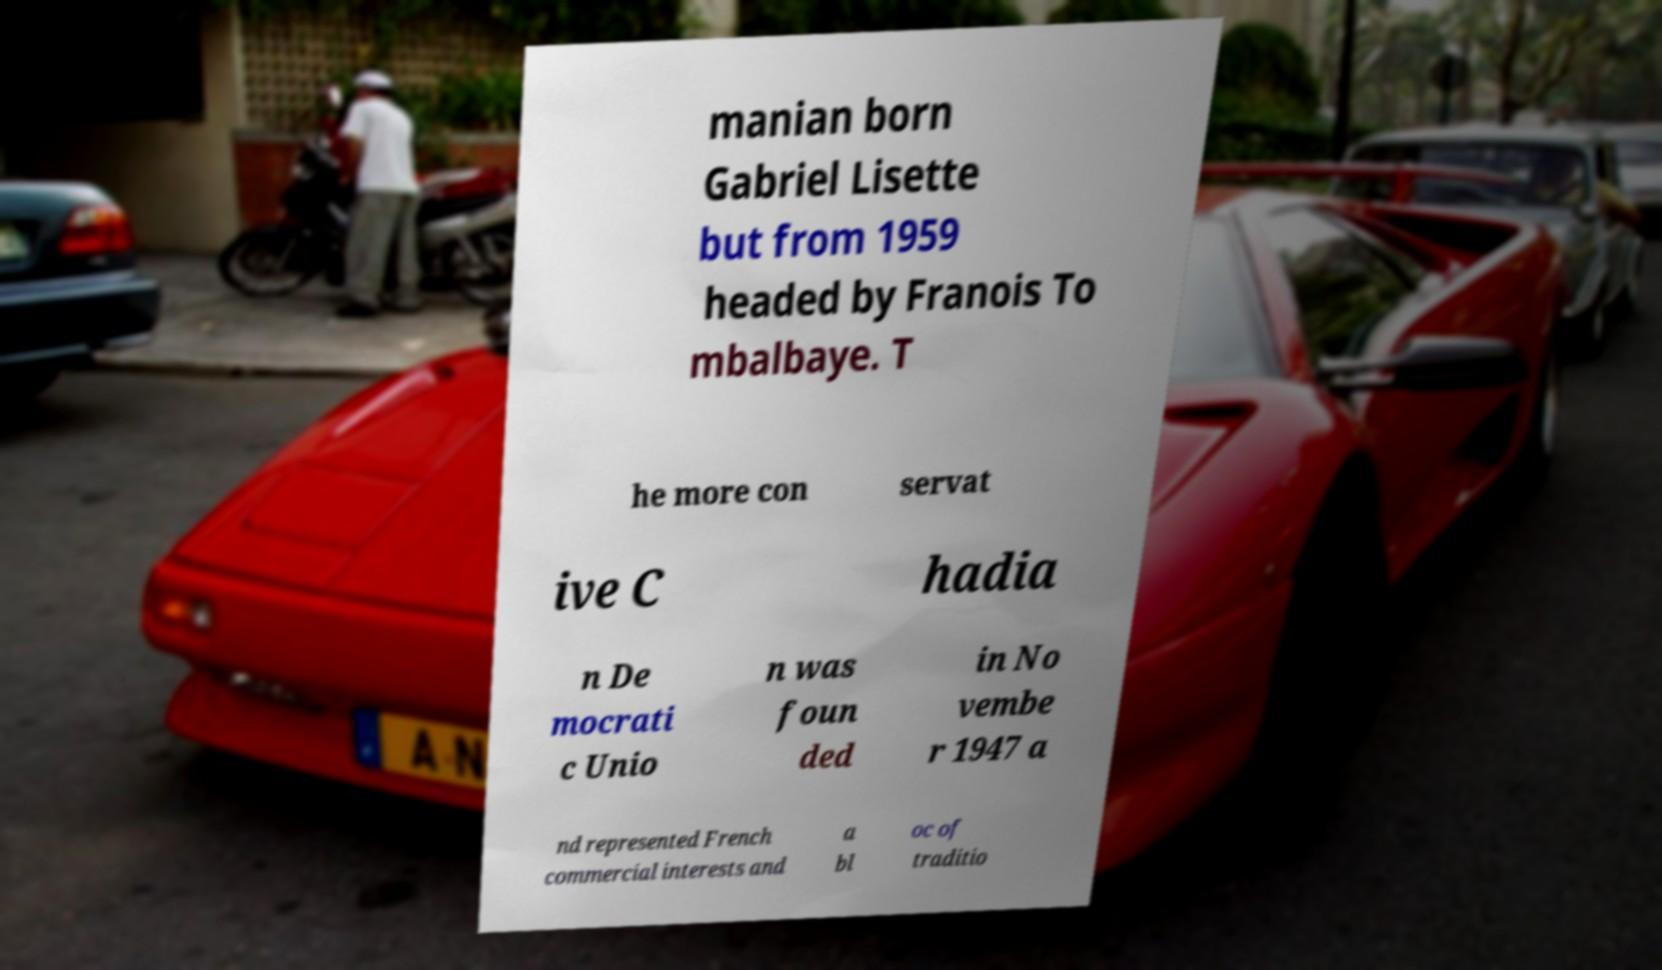Please identify and transcribe the text found in this image. manian born Gabriel Lisette but from 1959 headed by Franois To mbalbaye. T he more con servat ive C hadia n De mocrati c Unio n was foun ded in No vembe r 1947 a nd represented French commercial interests and a bl oc of traditio 